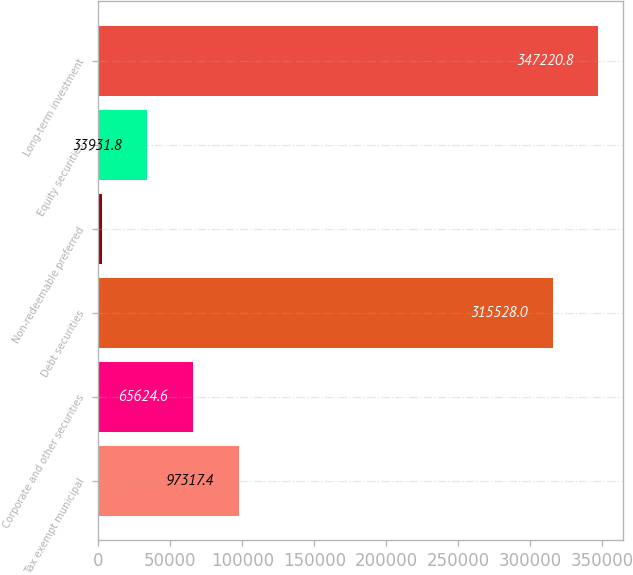Convert chart to OTSL. <chart><loc_0><loc_0><loc_500><loc_500><bar_chart><fcel>Tax exempt municipal<fcel>Corporate and other securities<fcel>Debt securities<fcel>Non-redeemable preferred<fcel>Equity securities<fcel>Long-term investment<nl><fcel>97317.4<fcel>65624.6<fcel>315528<fcel>2239<fcel>33931.8<fcel>347221<nl></chart> 